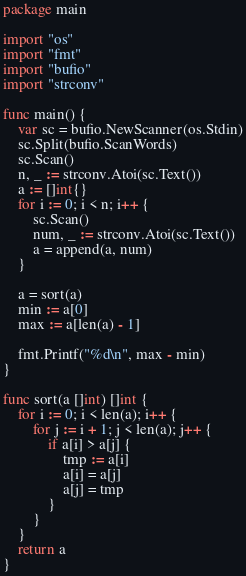<code> <loc_0><loc_0><loc_500><loc_500><_Go_>package main

import "os"
import "fmt"
import "bufio"
import "strconv"

func main() {
    var sc = bufio.NewScanner(os.Stdin)
    sc.Split(bufio.ScanWords)
    sc.Scan()
    n, _ := strconv.Atoi(sc.Text())
    a := []int{}
    for i := 0; i < n; i++ {
        sc.Scan()
        num, _ := strconv.Atoi(sc.Text())
        a = append(a, num)
    }

    a = sort(a)
    min := a[0]
    max := a[len(a) - 1]

    fmt.Printf("%d\n", max - min)
}

func sort(a []int) []int {
    for i := 0; i < len(a); i++ {
        for j := i + 1; j < len(a); j++ {
            if a[i] > a[j] {
                tmp := a[i]
                a[i] = a[j]
                a[j] = tmp
            }
        }
    }
    return a
}
</code> 